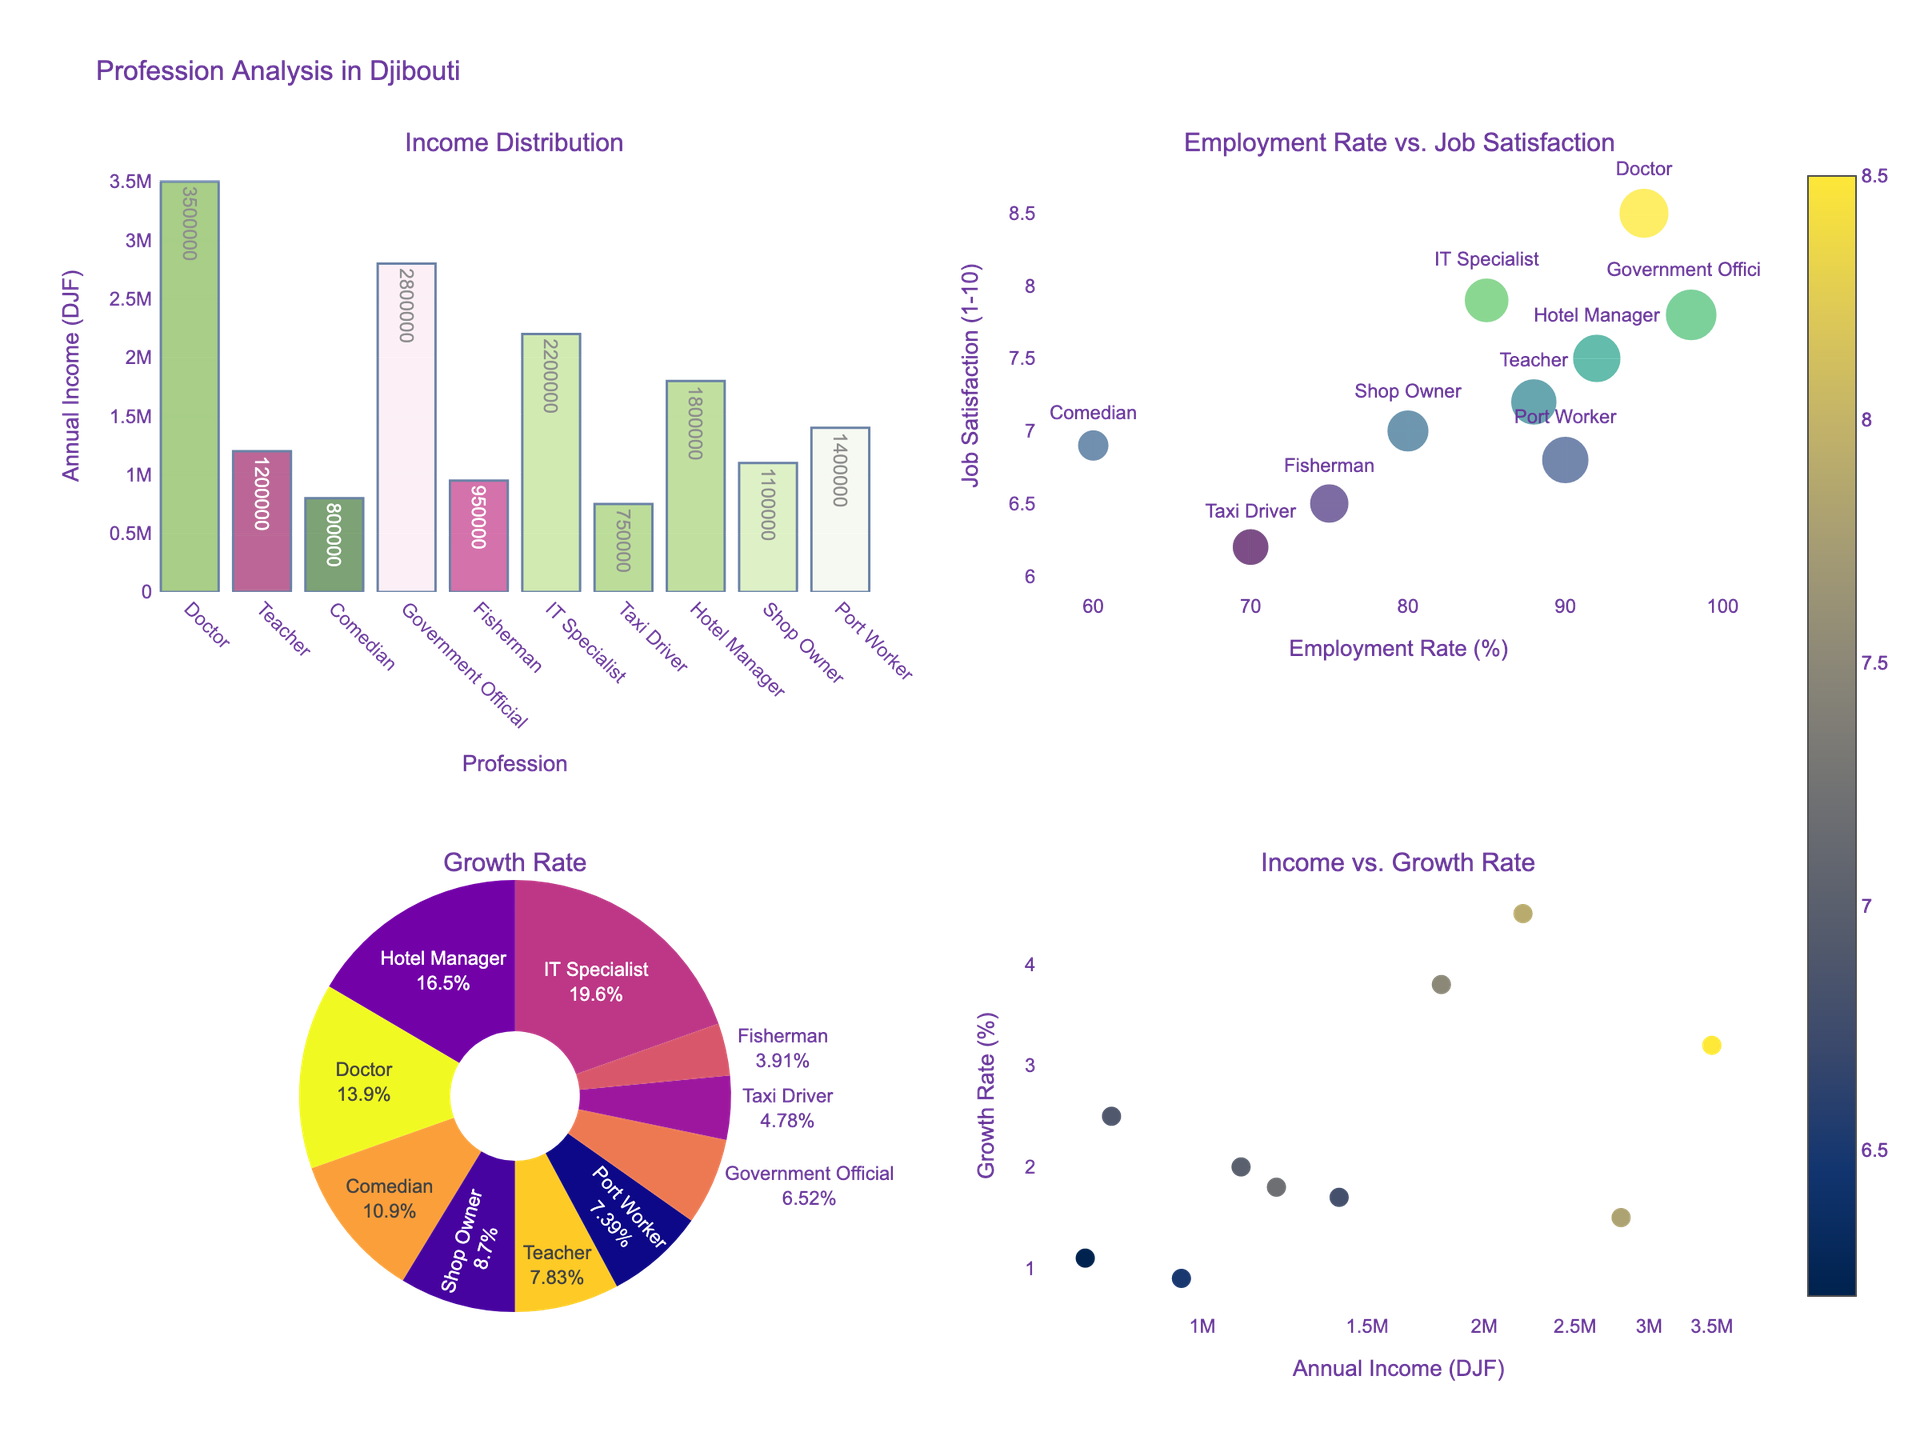what profession has the highest average annual income? By looking at the bar chart in the "Income Distribution" subplot, the profession with the highest bar represents the highest income. In this case, that's the doctor profession.
Answer: Doctor What is the average job satisfaction for employment rates above 80%? From the scatter plot "Employment Rate vs. Job Satisfaction," identify the points where employment rates are above 80%. These professions are Doctor, Teacher, Government Official, Hotel Manager, Port Worker, and IT Specialist. Then, average their job satisfaction: (8.5 + 7.2 + 7.8 + 7.5 + 6.8 + 7.9) / 6 = 45.7 / 6 = 7.62.
Answer: 7.62 Which profession has the smallest employment rate and what is its corresponding job satisfaction? From the scatter plot in the "Employment Rate vs. Job Satisfaction" subplot, the profession with the lowest employment rate is Comedian. The corresponding job satisfaction is 6.9.
Answer: Comedian, 6.9 What is the total growth rate percentage of the professions? The pie chart in the "Growth Rate" subplot provides these percentages. Adding up all the displayed percentages gives us: 3.2 + 1.8 + 2.5 + 1.5 + 0.9 + 4.5 + 1.1 + 3.8 + 2.0 + 1.7 = 23.0%.
Answer: 23.0 Is there a correlation between average annual income and growth rate? The scatter plot in the "Income vs. Growth Rate" subplot will help. A close look at the dots doesn't show a clear linear pattern indicating a strong correlation.
Answer: No clear correlation Which profession appears to have the highest growth rate? In the pie chart "Growth Rate," the profession with the largest slice represents the highest growth rate. IT Specialist shows the largest slice.
Answer: IT Specialist Which profession has the highest job satisfaction score, and could you rate how it compares to comedians? From the scatter plot "Employment Rate vs. Job Satisfaction," Doctor has the highest job satisfaction score of 8.5. Comparing this to Comedian's score of 6.9, Doctor rates significantly higher.
Answer: Doctor, 8.5 vs. 6.9 How does the income of a comedian compare with a taxi driver? Looking at the bar chart "Income Distribution," the bar for comedian is slightly above that of a taxi driver. Comedian has an income of DJF 800,000, while Taxi Driver has DJF 750,000.
Answer: Comedian > Taxi Driver 